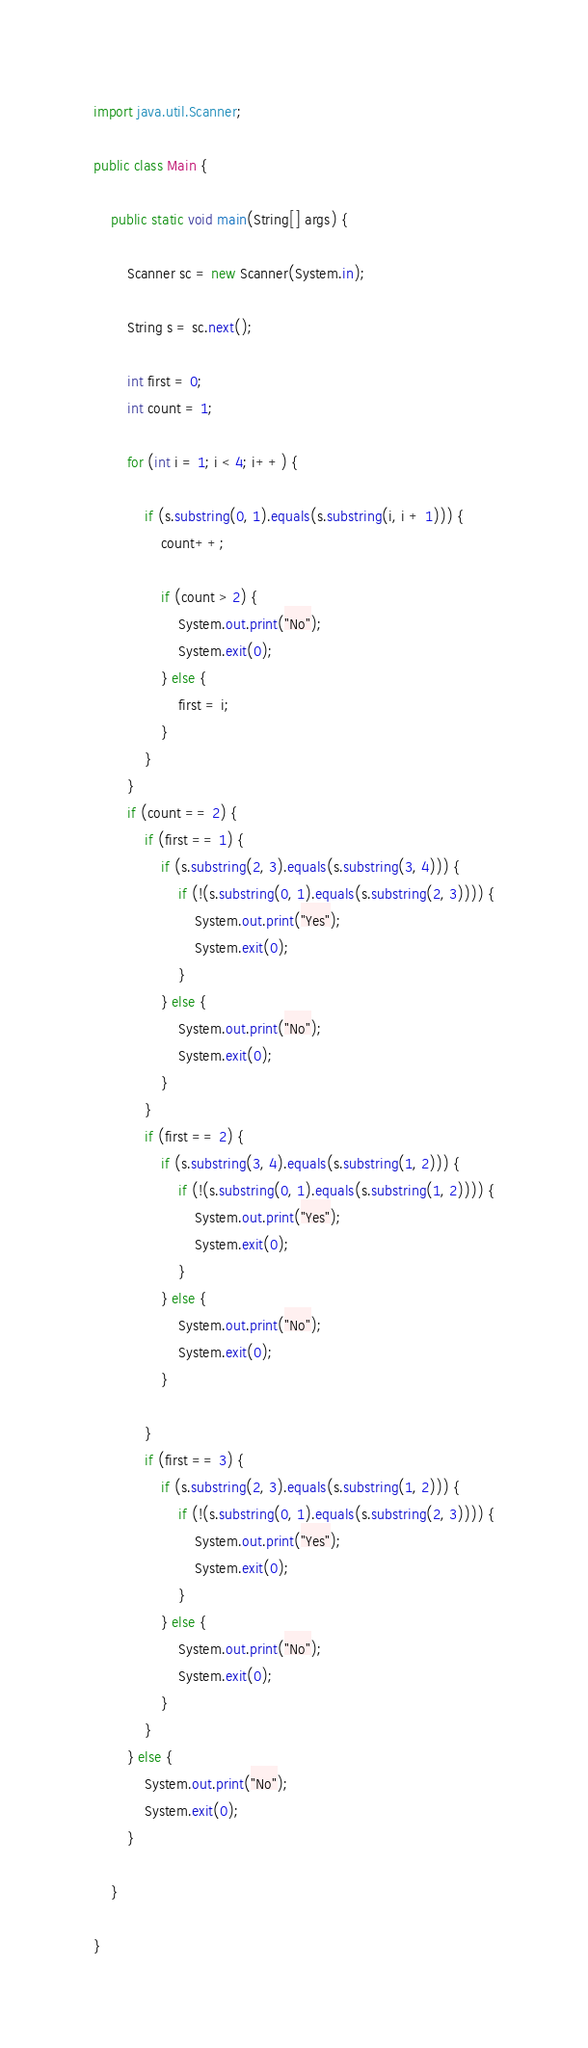Convert code to text. <code><loc_0><loc_0><loc_500><loc_500><_Java_>import java.util.Scanner;

public class Main {

	public static void main(String[] args) {

		Scanner sc = new Scanner(System.in);

		String s = sc.next();

		int first = 0;
		int count = 1;

		for (int i = 1; i < 4; i++) {

			if (s.substring(0, 1).equals(s.substring(i, i + 1))) {
				count++;

				if (count > 2) {
					System.out.print("No");
					System.exit(0);
				} else {
					first = i;
				}
			}
		}
		if (count == 2) {
			if (first == 1) {
				if (s.substring(2, 3).equals(s.substring(3, 4))) {
					if (!(s.substring(0, 1).equals(s.substring(2, 3)))) {
						System.out.print("Yes");
						System.exit(0);
					}
				} else {
					System.out.print("No");
					System.exit(0);
				}
			}
			if (first == 2) {
				if (s.substring(3, 4).equals(s.substring(1, 2))) {
					if (!(s.substring(0, 1).equals(s.substring(1, 2)))) {
						System.out.print("Yes");
						System.exit(0);
					}
				} else {
					System.out.print("No");
					System.exit(0);
				}

			}
			if (first == 3) {
				if (s.substring(2, 3).equals(s.substring(1, 2))) {
					if (!(s.substring(0, 1).equals(s.substring(2, 3)))) {
						System.out.print("Yes");
						System.exit(0);
					}
				} else {
					System.out.print("No");
					System.exit(0);
				}
			}
		} else {
			System.out.print("No");
			System.exit(0);
		}

	}

}</code> 